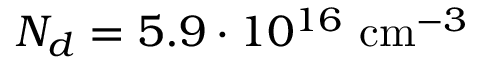<formula> <loc_0><loc_0><loc_500><loc_500>N _ { d } = 5 . 9 \cdot 1 0 ^ { 1 6 } { c m ^ { - 3 } }</formula> 